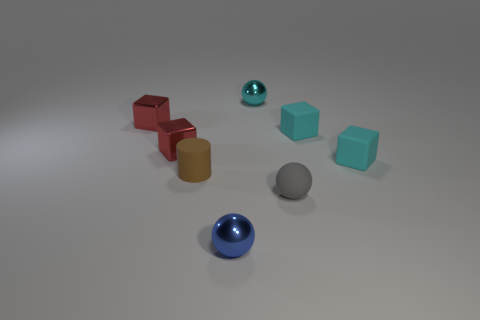Add 1 small metallic spheres. How many objects exist? 9 Subtract all cylinders. How many objects are left? 7 Add 4 tiny metal objects. How many tiny metal objects are left? 8 Add 4 shiny spheres. How many shiny spheres exist? 6 Subtract 0 yellow blocks. How many objects are left? 8 Subtract all tiny cubes. Subtract all cyan rubber cubes. How many objects are left? 2 